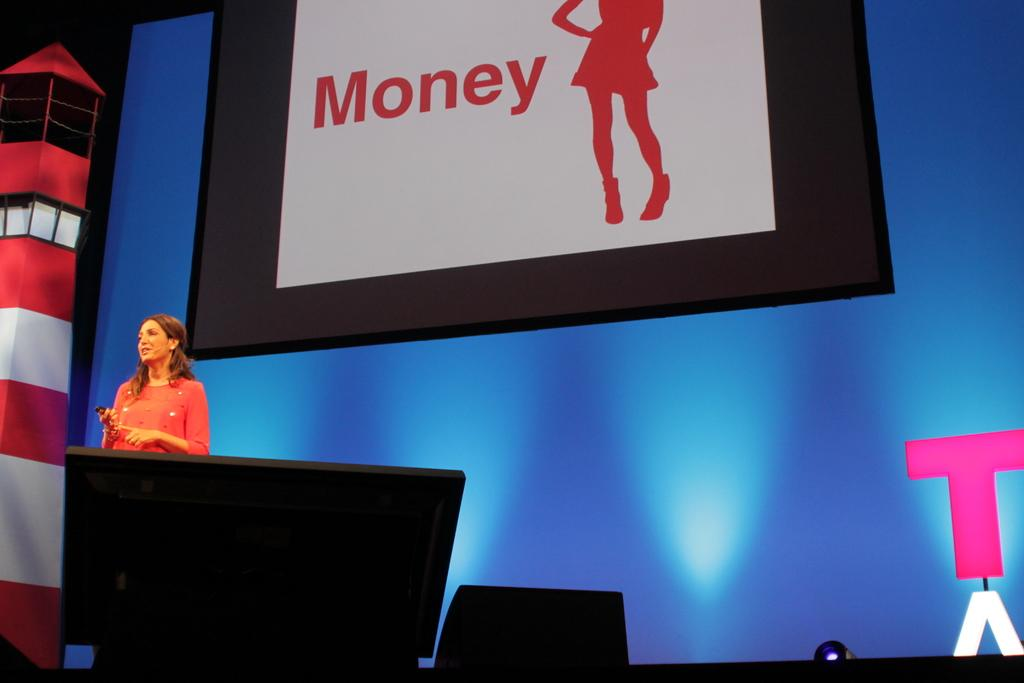<image>
Render a clear and concise summary of the photo. A sign featuring the word money in red on white. 